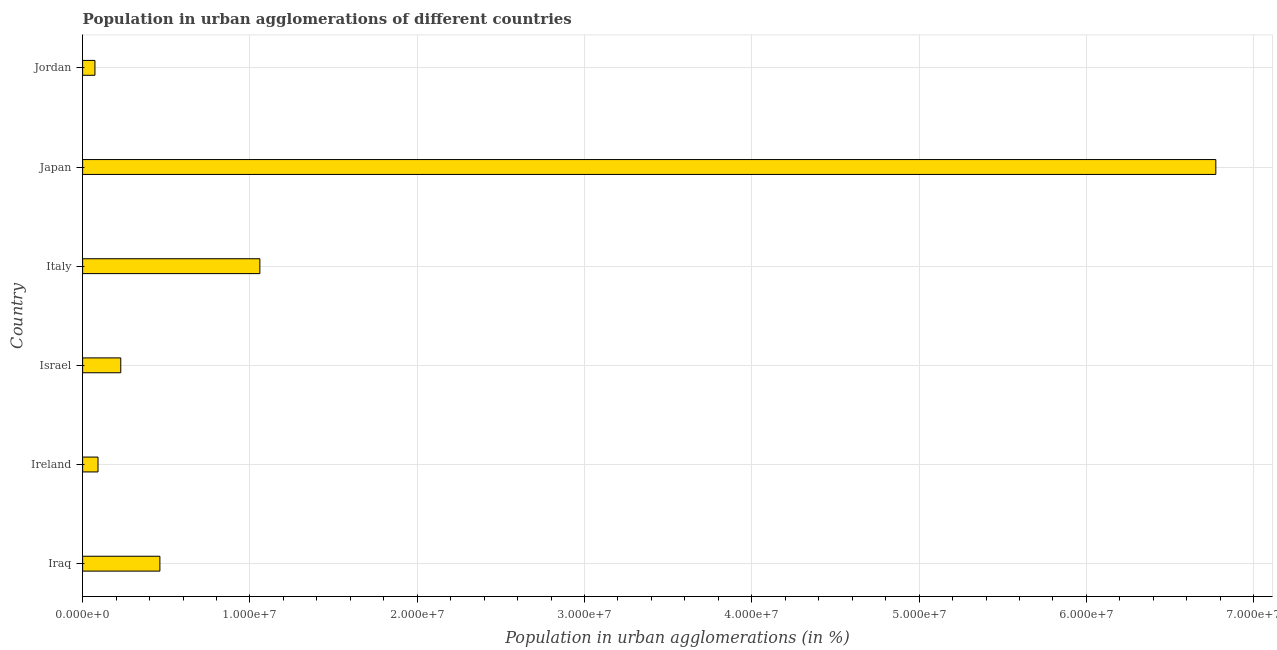Does the graph contain grids?
Ensure brevity in your answer.  Yes. What is the title of the graph?
Your response must be concise. Population in urban agglomerations of different countries. What is the label or title of the X-axis?
Your answer should be compact. Population in urban agglomerations (in %). What is the population in urban agglomerations in Ireland?
Ensure brevity in your answer.  9.20e+05. Across all countries, what is the maximum population in urban agglomerations?
Your answer should be compact. 6.77e+07. Across all countries, what is the minimum population in urban agglomerations?
Your answer should be very brief. 7.36e+05. In which country was the population in urban agglomerations maximum?
Your answer should be very brief. Japan. In which country was the population in urban agglomerations minimum?
Your response must be concise. Jordan. What is the sum of the population in urban agglomerations?
Your answer should be very brief. 8.69e+07. What is the difference between the population in urban agglomerations in Iraq and Ireland?
Your answer should be very brief. 3.70e+06. What is the average population in urban agglomerations per country?
Provide a succinct answer. 1.45e+07. What is the median population in urban agglomerations?
Ensure brevity in your answer.  3.45e+06. What is the ratio of the population in urban agglomerations in Ireland to that in Jordan?
Make the answer very short. 1.25. Is the population in urban agglomerations in Italy less than that in Japan?
Ensure brevity in your answer.  Yes. What is the difference between the highest and the second highest population in urban agglomerations?
Provide a short and direct response. 5.71e+07. Is the sum of the population in urban agglomerations in Ireland and Italy greater than the maximum population in urban agglomerations across all countries?
Keep it short and to the point. No. What is the difference between the highest and the lowest population in urban agglomerations?
Offer a very short reply. 6.70e+07. Are all the bars in the graph horizontal?
Keep it short and to the point. Yes. Are the values on the major ticks of X-axis written in scientific E-notation?
Give a very brief answer. Yes. What is the Population in urban agglomerations (in %) in Iraq?
Keep it short and to the point. 4.62e+06. What is the Population in urban agglomerations (in %) in Ireland?
Offer a very short reply. 9.20e+05. What is the Population in urban agglomerations (in %) in Israel?
Offer a terse response. 2.28e+06. What is the Population in urban agglomerations (in %) of Italy?
Your answer should be compact. 1.06e+07. What is the Population in urban agglomerations (in %) of Japan?
Offer a very short reply. 6.77e+07. What is the Population in urban agglomerations (in %) in Jordan?
Your response must be concise. 7.36e+05. What is the difference between the Population in urban agglomerations (in %) in Iraq and Ireland?
Provide a succinct answer. 3.70e+06. What is the difference between the Population in urban agglomerations (in %) in Iraq and Israel?
Provide a succinct answer. 2.34e+06. What is the difference between the Population in urban agglomerations (in %) in Iraq and Italy?
Make the answer very short. -5.98e+06. What is the difference between the Population in urban agglomerations (in %) in Iraq and Japan?
Your response must be concise. -6.31e+07. What is the difference between the Population in urban agglomerations (in %) in Iraq and Jordan?
Your response must be concise. 3.88e+06. What is the difference between the Population in urban agglomerations (in %) in Ireland and Israel?
Keep it short and to the point. -1.36e+06. What is the difference between the Population in urban agglomerations (in %) in Ireland and Italy?
Provide a succinct answer. -9.67e+06. What is the difference between the Population in urban agglomerations (in %) in Ireland and Japan?
Your answer should be very brief. -6.68e+07. What is the difference between the Population in urban agglomerations (in %) in Ireland and Jordan?
Keep it short and to the point. 1.84e+05. What is the difference between the Population in urban agglomerations (in %) in Israel and Italy?
Provide a succinct answer. -8.31e+06. What is the difference between the Population in urban agglomerations (in %) in Israel and Japan?
Provide a short and direct response. -6.55e+07. What is the difference between the Population in urban agglomerations (in %) in Israel and Jordan?
Provide a short and direct response. 1.54e+06. What is the difference between the Population in urban agglomerations (in %) in Italy and Japan?
Ensure brevity in your answer.  -5.71e+07. What is the difference between the Population in urban agglomerations (in %) in Italy and Jordan?
Provide a short and direct response. 9.86e+06. What is the difference between the Population in urban agglomerations (in %) in Japan and Jordan?
Provide a short and direct response. 6.70e+07. What is the ratio of the Population in urban agglomerations (in %) in Iraq to that in Ireland?
Your answer should be compact. 5.02. What is the ratio of the Population in urban agglomerations (in %) in Iraq to that in Israel?
Make the answer very short. 2.03. What is the ratio of the Population in urban agglomerations (in %) in Iraq to that in Italy?
Offer a terse response. 0.44. What is the ratio of the Population in urban agglomerations (in %) in Iraq to that in Japan?
Your answer should be very brief. 0.07. What is the ratio of the Population in urban agglomerations (in %) in Iraq to that in Jordan?
Your answer should be very brief. 6.28. What is the ratio of the Population in urban agglomerations (in %) in Ireland to that in Israel?
Your answer should be very brief. 0.4. What is the ratio of the Population in urban agglomerations (in %) in Ireland to that in Italy?
Offer a very short reply. 0.09. What is the ratio of the Population in urban agglomerations (in %) in Ireland to that in Japan?
Your response must be concise. 0.01. What is the ratio of the Population in urban agglomerations (in %) in Ireland to that in Jordan?
Ensure brevity in your answer.  1.25. What is the ratio of the Population in urban agglomerations (in %) in Israel to that in Italy?
Your response must be concise. 0.21. What is the ratio of the Population in urban agglomerations (in %) in Israel to that in Japan?
Provide a succinct answer. 0.03. What is the ratio of the Population in urban agglomerations (in %) in Israel to that in Jordan?
Give a very brief answer. 3.1. What is the ratio of the Population in urban agglomerations (in %) in Italy to that in Japan?
Your answer should be compact. 0.16. What is the ratio of the Population in urban agglomerations (in %) in Japan to that in Jordan?
Provide a succinct answer. 92.07. 